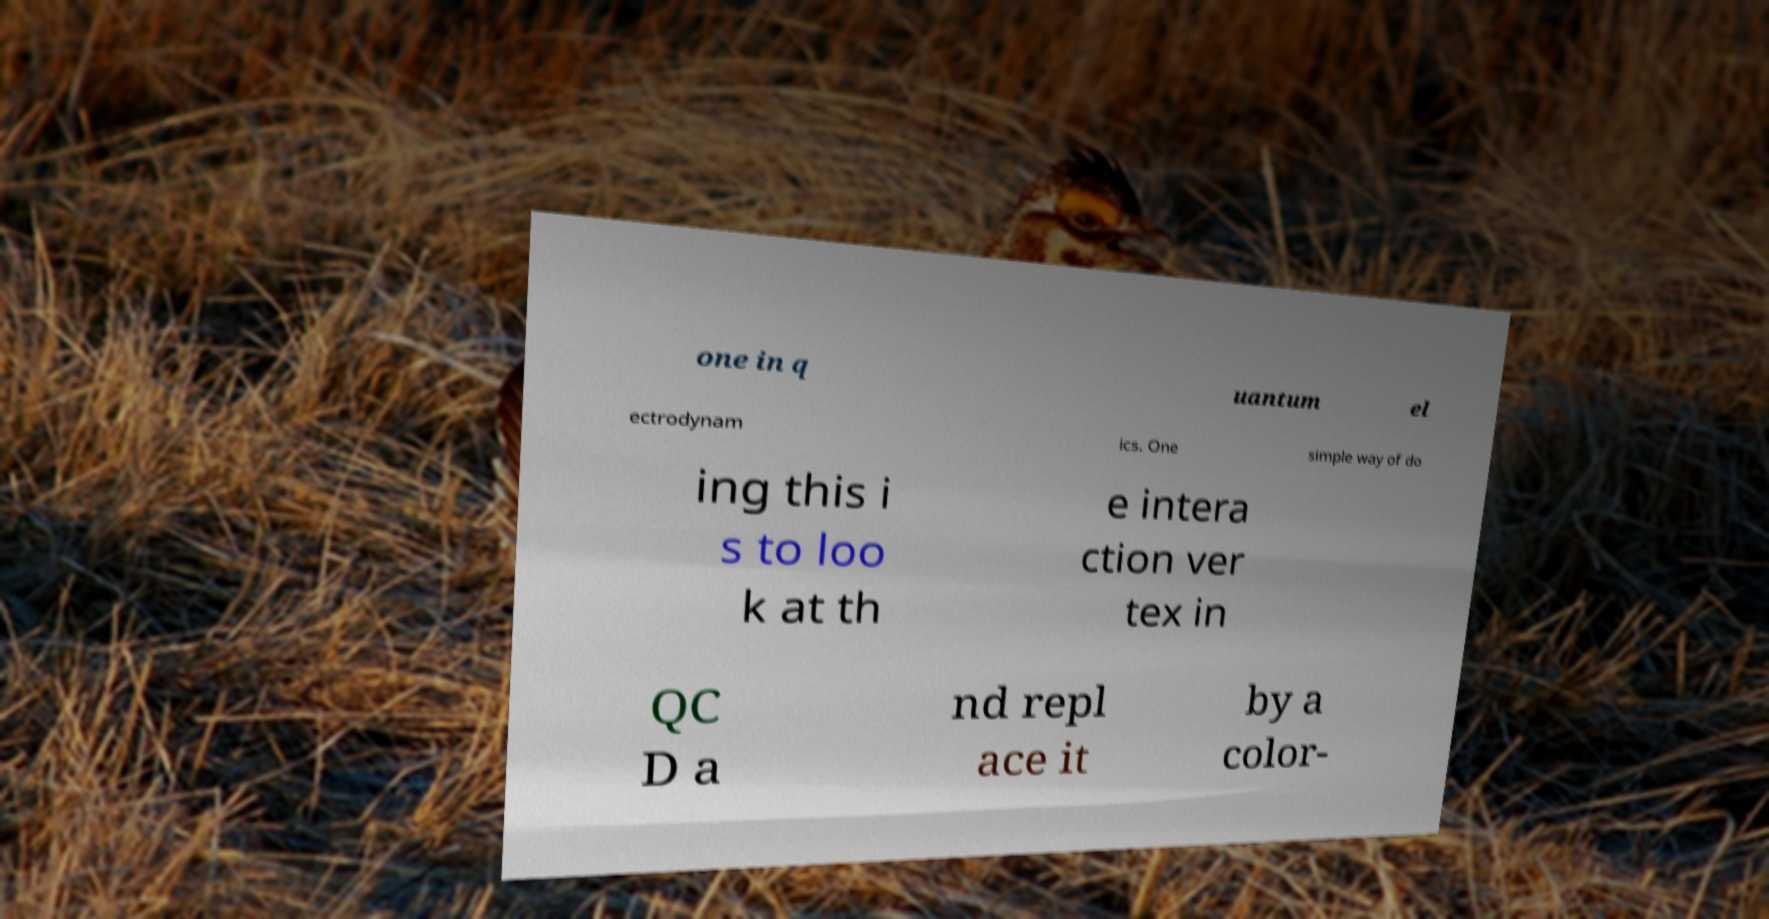Can you read and provide the text displayed in the image?This photo seems to have some interesting text. Can you extract and type it out for me? one in q uantum el ectrodynam ics. One simple way of do ing this i s to loo k at th e intera ction ver tex in QC D a nd repl ace it by a color- 